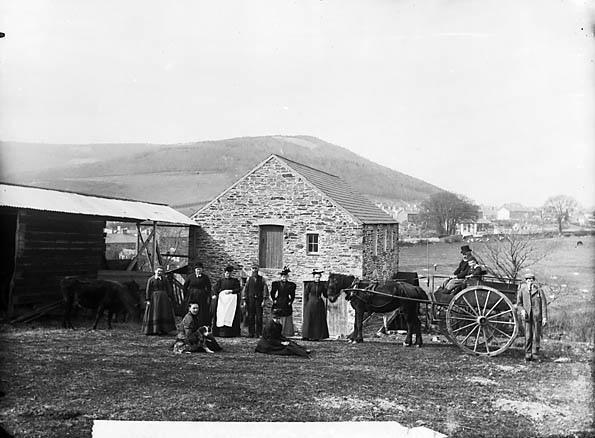How many horses are in this photograph?
Give a very brief answer. 1. How many people are in the picture?
Give a very brief answer. 10. How many people are in the carriage?
Give a very brief answer. 2. How many horses are in the picture?
Give a very brief answer. 1. 